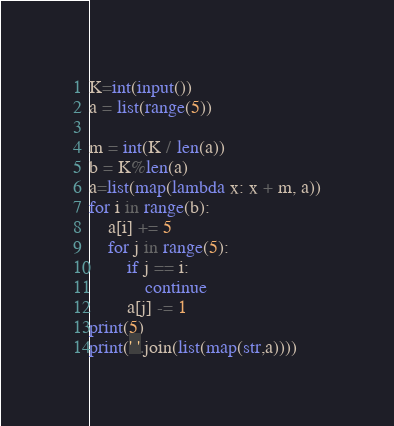<code> <loc_0><loc_0><loc_500><loc_500><_Python_>K=int(input())
a = list(range(5))

m = int(K / len(a))
b = K%len(a)
a=list(map(lambda x: x + m, a))
for i in range(b):
    a[i] += 5
    for j in range(5):
        if j == i:
            continue
        a[j] -= 1
print(5)
print(' '.join(list(map(str,a))))</code> 